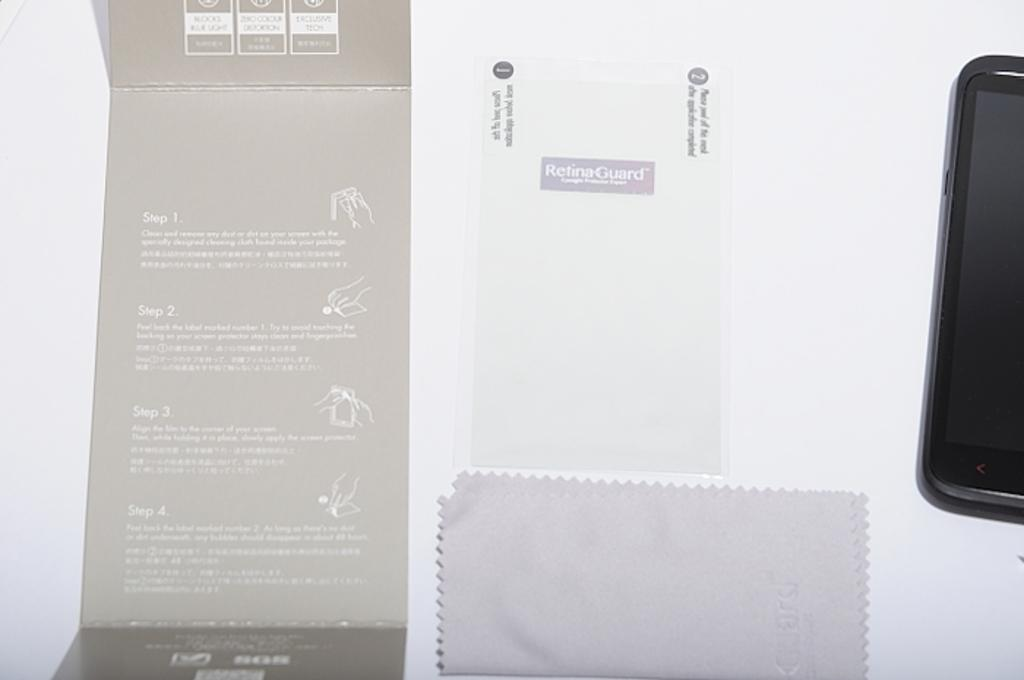<image>
Create a compact narrative representing the image presented. A RetinaGuard machine has an instruction panel on the left side. 